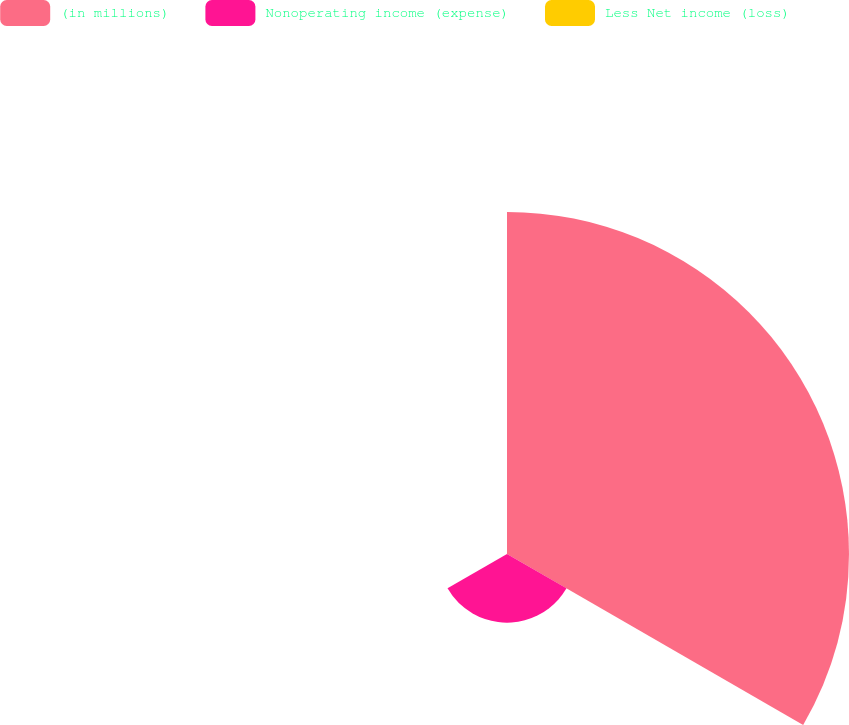<chart> <loc_0><loc_0><loc_500><loc_500><pie_chart><fcel>(in millions)<fcel>Nonoperating income (expense)<fcel>Less Net income (loss)<nl><fcel>83.21%<fcel>16.71%<fcel>0.08%<nl></chart> 